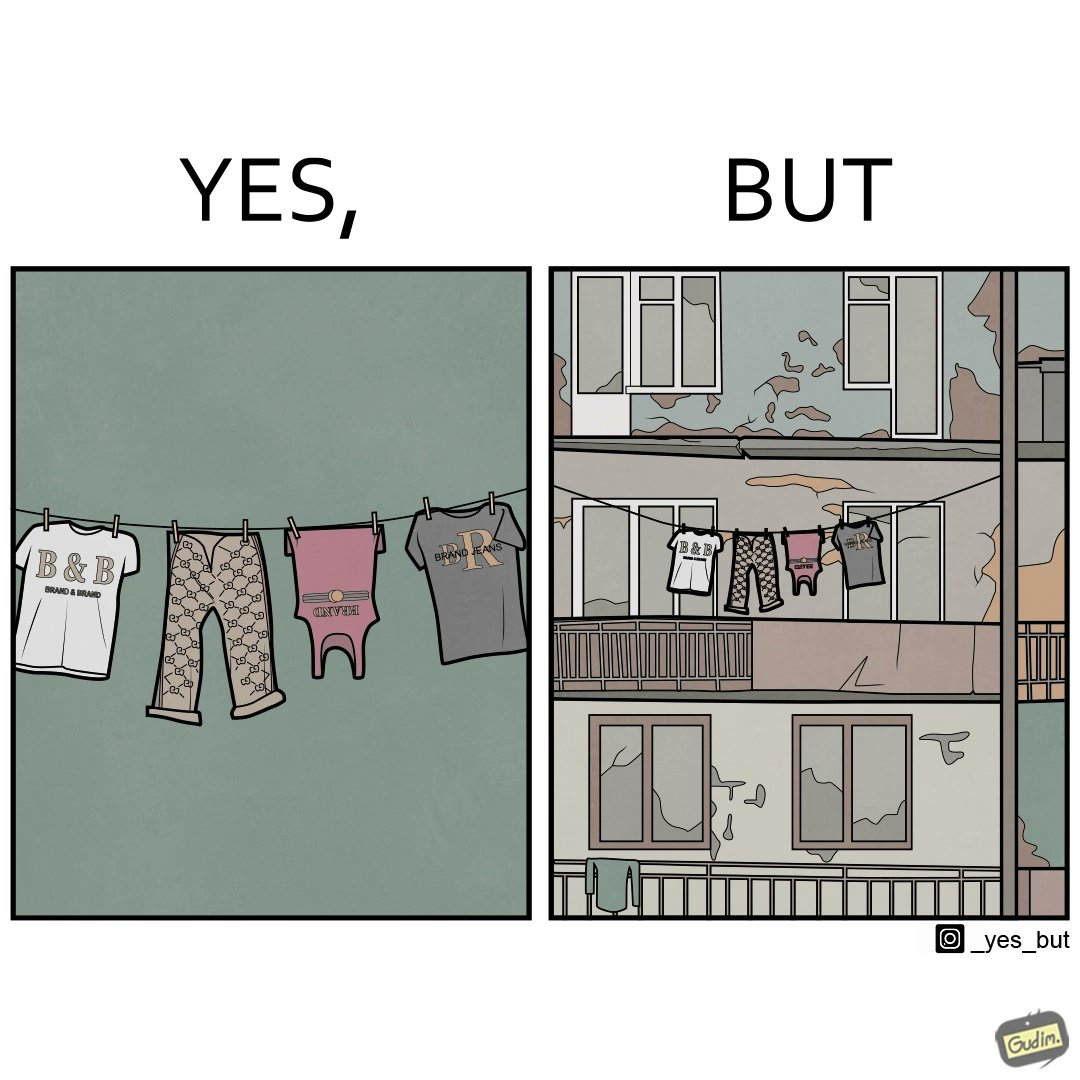Describe what you see in the left and right parts of this image. In the left part of the image: The image is showing branded clothes hanging on a wire. In the right part of the image: The image is showing a very old, dirty and broken house. 